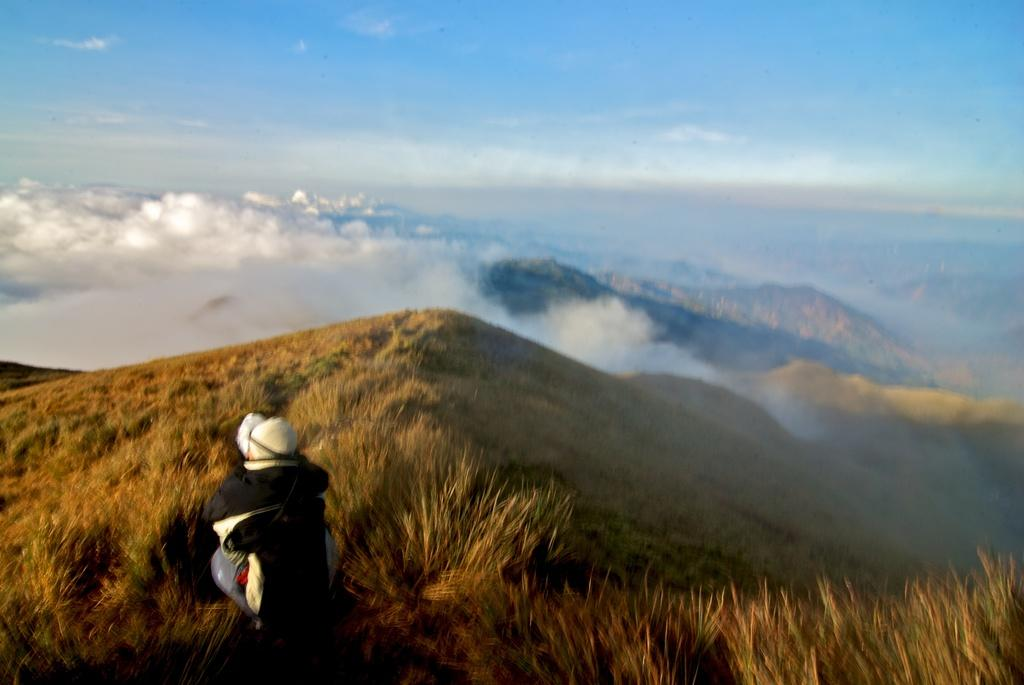Where was the image taken? The image was clicked outside. What can be seen in the foreground of the image? There is grass in the foreground of the image. What is the person in the foreground doing? The person is squatting on the ground in the foreground. What is visible in the background of the image? The sky and smoke are visible in the background of the image. What type of landscape can be seen in the background? Hills are present in the background of the image. What type of pig is causing the smoke in the image? There is no pig present in the image, and the smoke is not caused by any animal. 